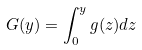Convert formula to latex. <formula><loc_0><loc_0><loc_500><loc_500>G ( y ) = \int _ { 0 } ^ { y } g ( z ) d z</formula> 